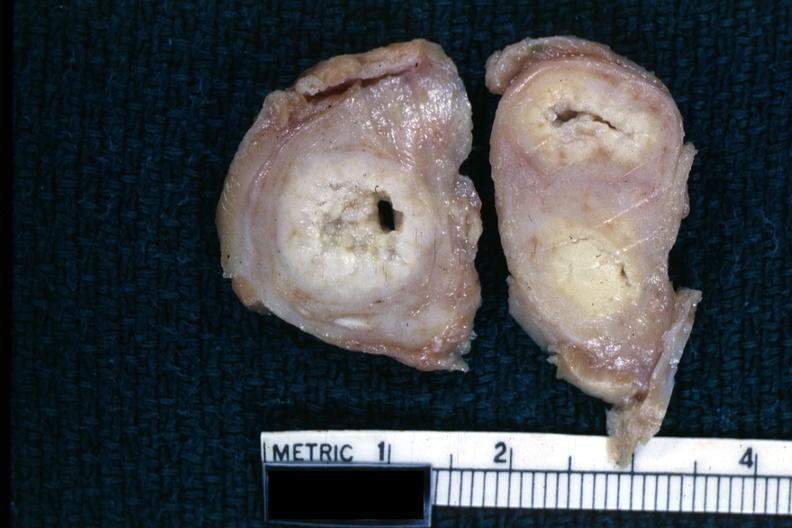s fallopian tube present?
Answer the question using a single word or phrase. Yes 